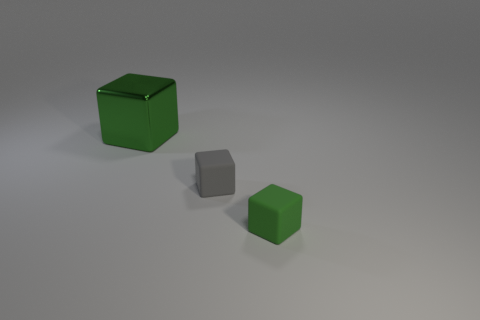What number of rubber things are either small blue objects or big things?
Keep it short and to the point. 0. There is a big shiny object; is its shape the same as the green thing in front of the metallic thing?
Ensure brevity in your answer.  Yes. Is the number of green blocks on the right side of the green shiny object greater than the number of large green things left of the tiny gray matte thing?
Provide a succinct answer. No. Is there any other thing that has the same color as the metallic thing?
Your response must be concise. Yes. Is there a green rubber object to the right of the green object on the left side of the green cube that is in front of the small gray rubber object?
Provide a short and direct response. Yes. Are there fewer tiny gray things that are behind the gray thing than blocks to the right of the big cube?
Offer a terse response. Yes. What is the gray object made of?
Your answer should be compact. Rubber. There is a metallic thing; does it have the same color as the small matte block on the right side of the tiny gray matte object?
Your answer should be very brief. Yes. There is a big object; how many tiny green cubes are to the right of it?
Provide a short and direct response. 1. Are there fewer small objects that are to the right of the big green shiny cube than tiny blue cubes?
Your answer should be very brief. No. 